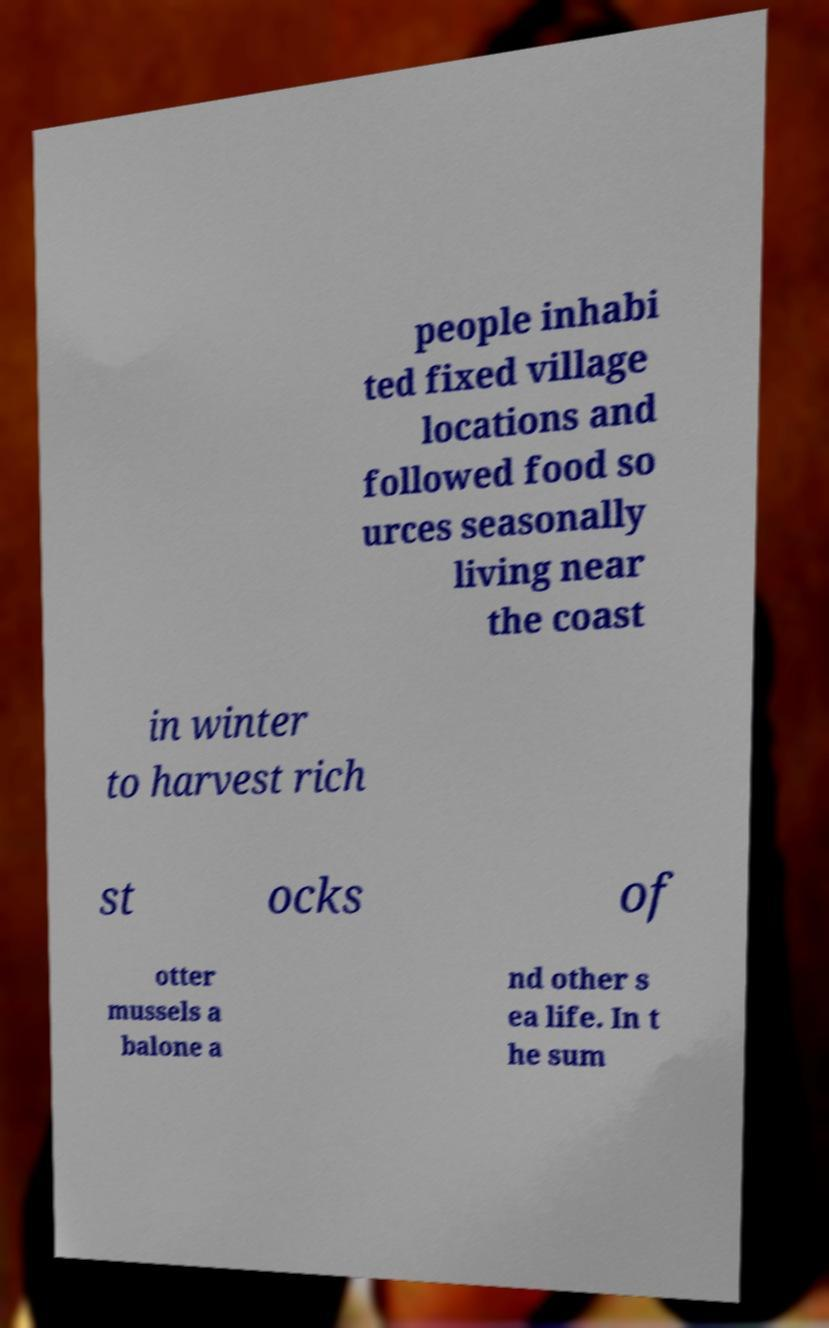There's text embedded in this image that I need extracted. Can you transcribe it verbatim? people inhabi ted fixed village locations and followed food so urces seasonally living near the coast in winter to harvest rich st ocks of otter mussels a balone a nd other s ea life. In t he sum 